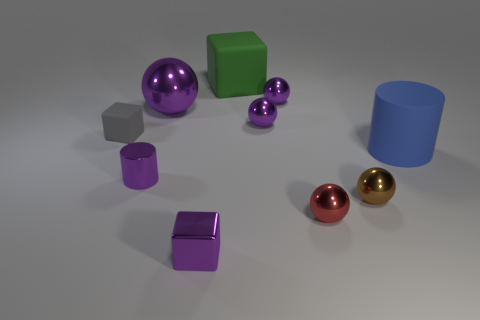Subtract all purple balls. How many were subtracted if there are1purple balls left? 2 Subtract all gray blocks. How many purple spheres are left? 3 Subtract 1 spheres. How many spheres are left? 4 Subtract all red spheres. How many spheres are left? 4 Subtract all large purple metal balls. How many balls are left? 4 Subtract all yellow balls. Subtract all yellow cubes. How many balls are left? 5 Subtract all cylinders. How many objects are left? 8 Subtract 0 blue cubes. How many objects are left? 10 Subtract all metallic spheres. Subtract all small spheres. How many objects are left? 1 Add 6 big rubber cylinders. How many big rubber cylinders are left? 7 